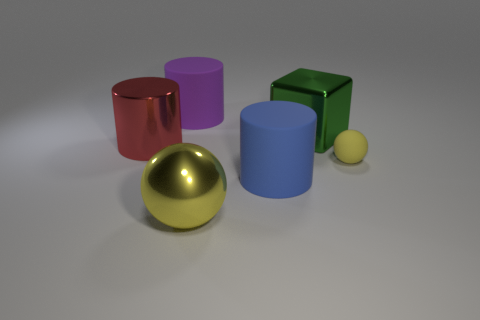Add 2 brown metal objects. How many objects exist? 8 Subtract all spheres. How many objects are left? 4 Subtract all large rubber things. Subtract all cylinders. How many objects are left? 1 Add 1 big yellow objects. How many big yellow objects are left? 2 Add 6 big green shiny blocks. How many big green shiny blocks exist? 7 Subtract 0 cyan balls. How many objects are left? 6 